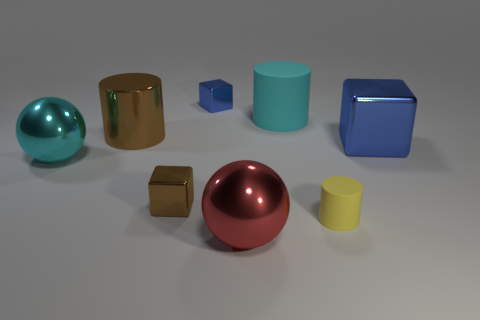Subtract all spheres. How many objects are left? 6 Add 8 purple metal balls. How many purple metal balls exist? 8 Subtract 0 red cubes. How many objects are left? 8 Subtract all cyan matte spheres. Subtract all yellow rubber cylinders. How many objects are left? 7 Add 8 red spheres. How many red spheres are left? 9 